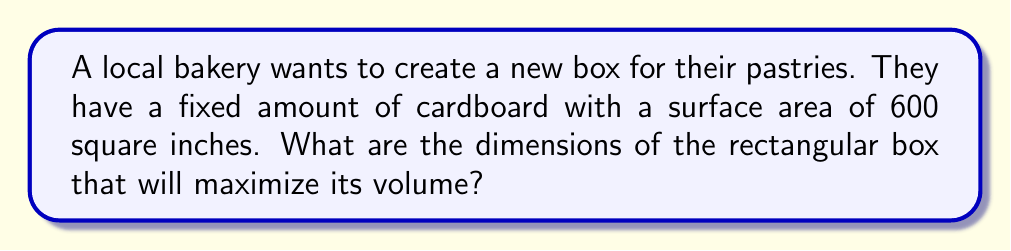What is the answer to this math problem? Let's approach this step-by-step:

1) Let the dimensions of the box be length $l$, width $w$, and height $h$.

2) The surface area of a rectangular box is given by:
   $$ S = 2lw + 2lh + 2wh $$
   We're told this equals 600 in², so:
   $$ 2lw + 2lh + 2wh = 600 $$

3) The volume of the box is:
   $$ V = lwh $$

4) To maximize volume, we need to express $V$ in terms of one variable. Let's choose $l$.

5) From the surface area equation, we can express $h$ in terms of $l$ and $w$:
   $$ h = \frac{300 - lw}{l + w} $$

6) Substituting this into the volume equation:
   $$ V = lw \cdot \frac{300 - lw}{l + w} = \frac{300lw - l^2w^2}{l + w} $$

7) For a fixed $l$, to maximize $V$, we need $w = l$ (this can be proved by taking partial derivatives, but we'll skip that for brevity).

8) Substituting $w = l$ into our volume equation:
   $$ V = \frac{300l^2 - l^4}{2l} = 150l - \frac{l^3}{2} $$

9) To find the maximum, we differentiate $V$ with respect to $l$ and set it to zero:
   $$ \frac{dV}{dl} = 150 - \frac{3l^2}{2} = 0 $$

10) Solving this:
    $$ 150 = \frac{3l^2}{2} $$
    $$ l^2 = 100 $$
    $$ l = 10 $$

11) Since $w = l$ and $h = \frac{300 - l^2}{2l}$, we have:
    $$ l = w = 10 \text{ inches} $$
    $$ h = \frac{300 - 100}{20} = 10 \text{ inches} $$

Therefore, the box should be a cube with all sides equal to 10 inches.
Answer: $10 \times 10 \times 10$ inches 